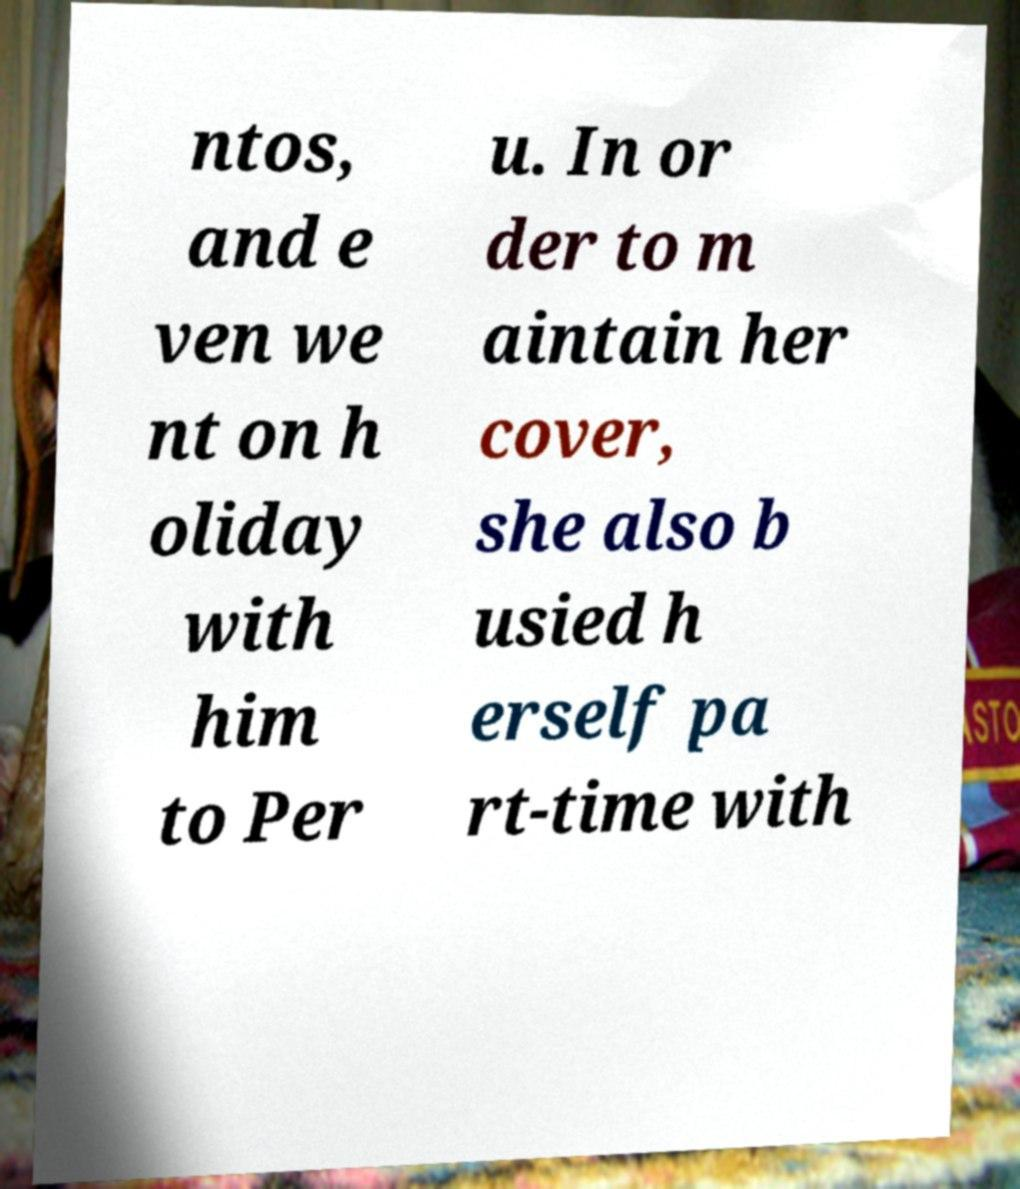I need the written content from this picture converted into text. Can you do that? ntos, and e ven we nt on h oliday with him to Per u. In or der to m aintain her cover, she also b usied h erself pa rt-time with 